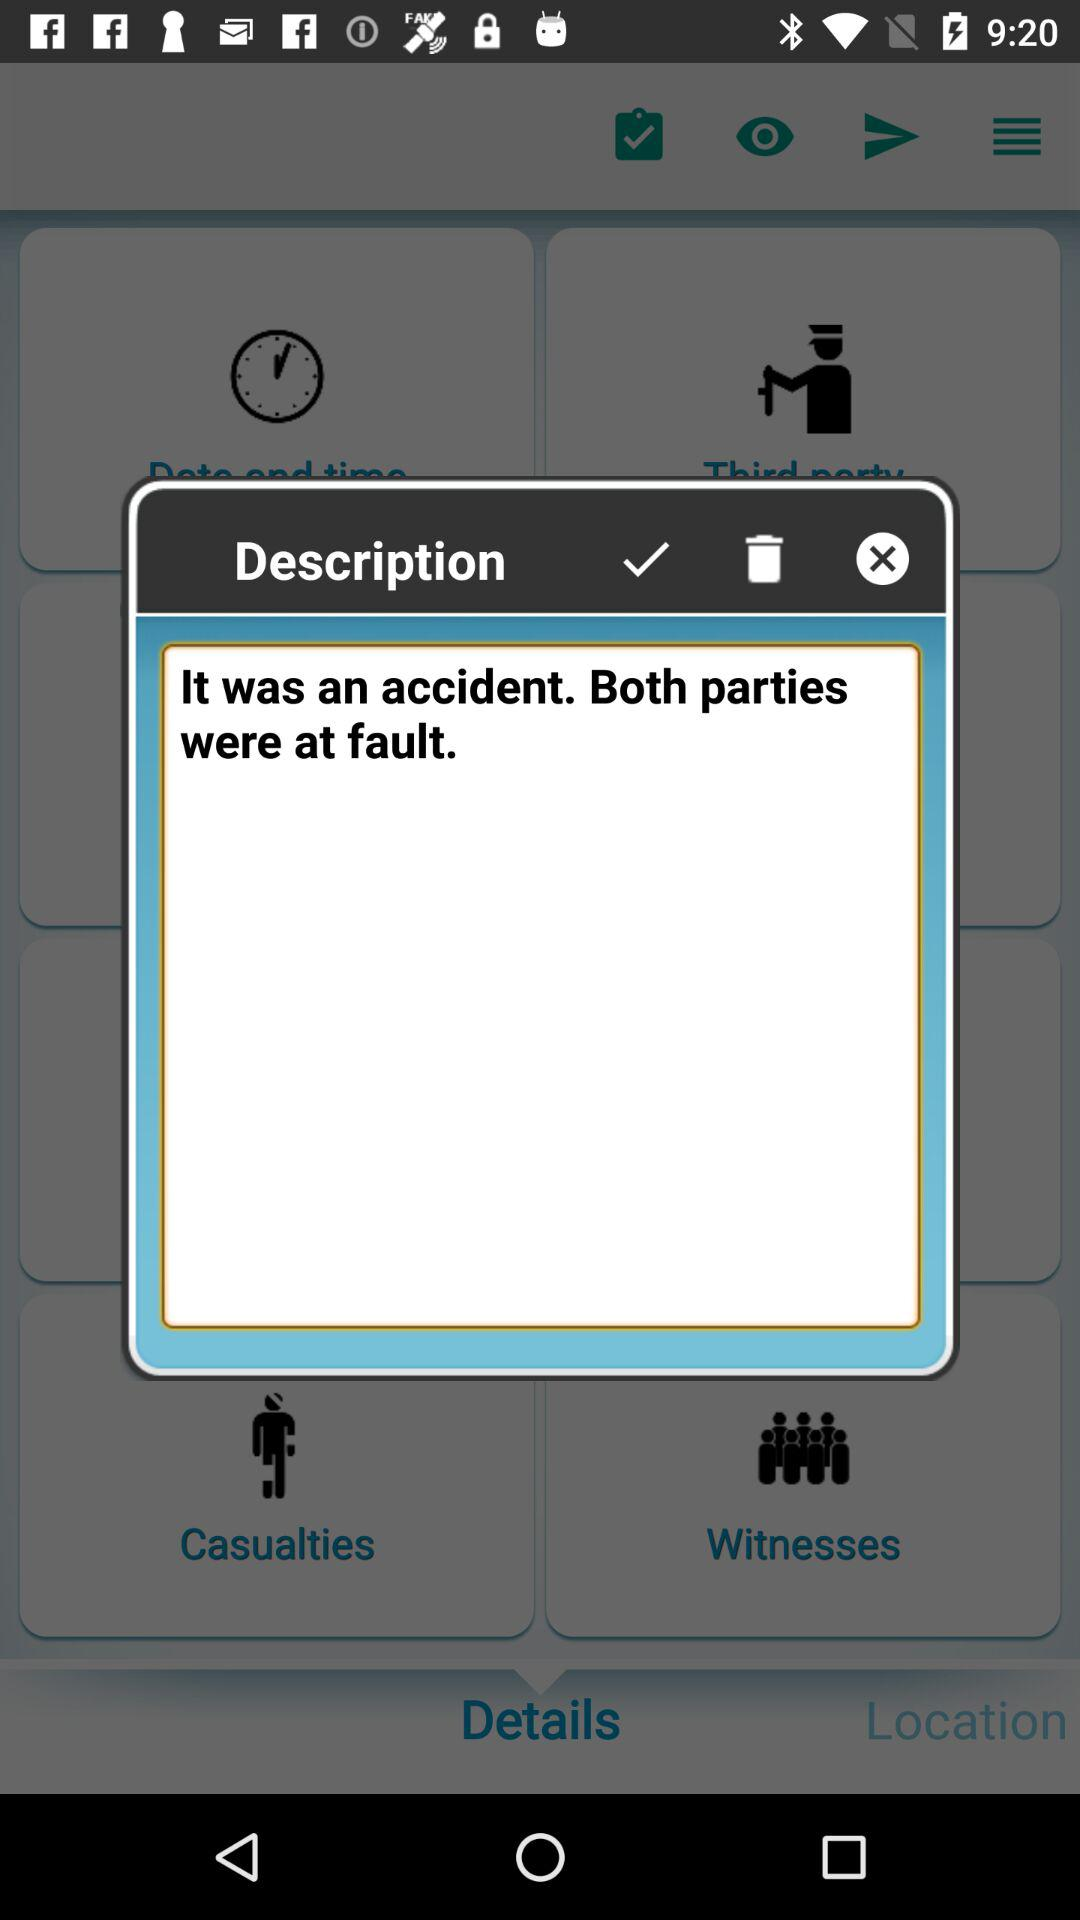What is the description? The description is "It was an accident. Both parties were at fault.". 